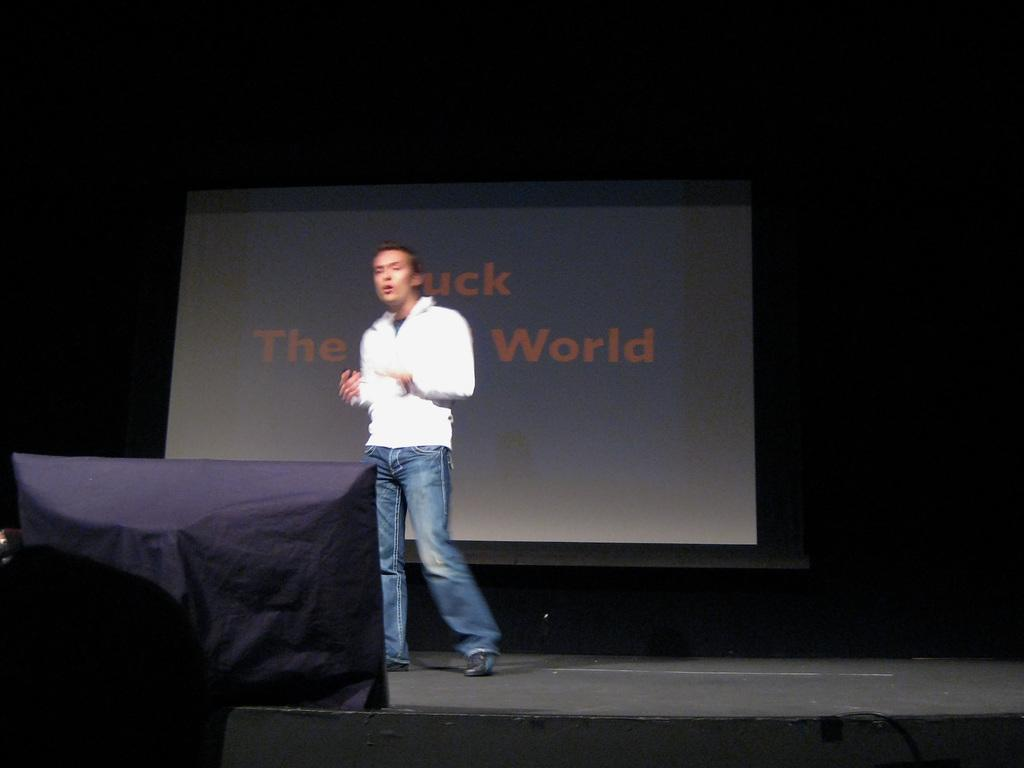What is the main subject of the image? There is a person standing in the image. What can be seen in the background of the image? There is a projection screen in the background of the image. What is covered by the purple cloth in the image? There is a purple cloth covering an object in the image. What type of basketball game is being played on the projection screen in the image? There is no basketball game visible on the projection screen in the image. What type of protest is taking place in the image? There is no protest present in the image; it features a person standing, a projection screen, and a purple cloth covering an object. 